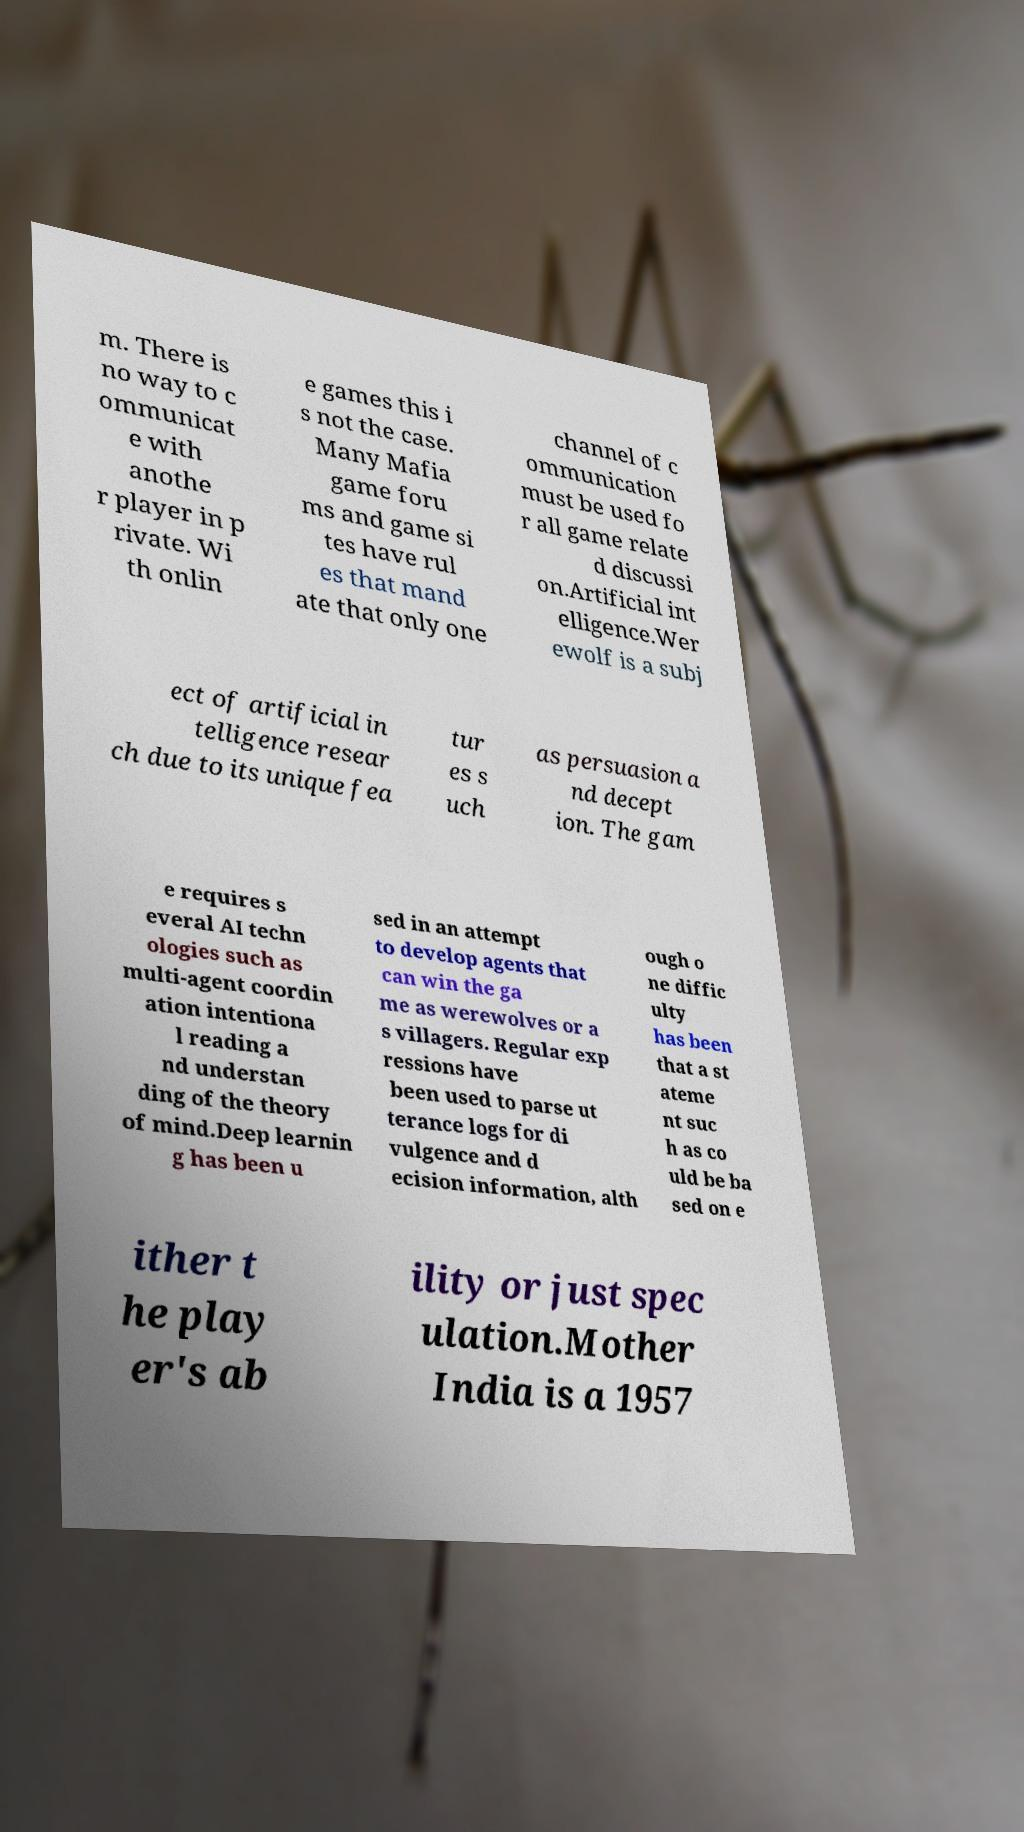Can you read and provide the text displayed in the image?This photo seems to have some interesting text. Can you extract and type it out for me? m. There is no way to c ommunicat e with anothe r player in p rivate. Wi th onlin e games this i s not the case. Many Mafia game foru ms and game si tes have rul es that mand ate that only one channel of c ommunication must be used fo r all game relate d discussi on.Artificial int elligence.Wer ewolf is a subj ect of artificial in telligence resear ch due to its unique fea tur es s uch as persuasion a nd decept ion. The gam e requires s everal AI techn ologies such as multi-agent coordin ation intentiona l reading a nd understan ding of the theory of mind.Deep learnin g has been u sed in an attempt to develop agents that can win the ga me as werewolves or a s villagers. Regular exp ressions have been used to parse ut terance logs for di vulgence and d ecision information, alth ough o ne diffic ulty has been that a st ateme nt suc h as co uld be ba sed on e ither t he play er's ab ility or just spec ulation.Mother India is a 1957 